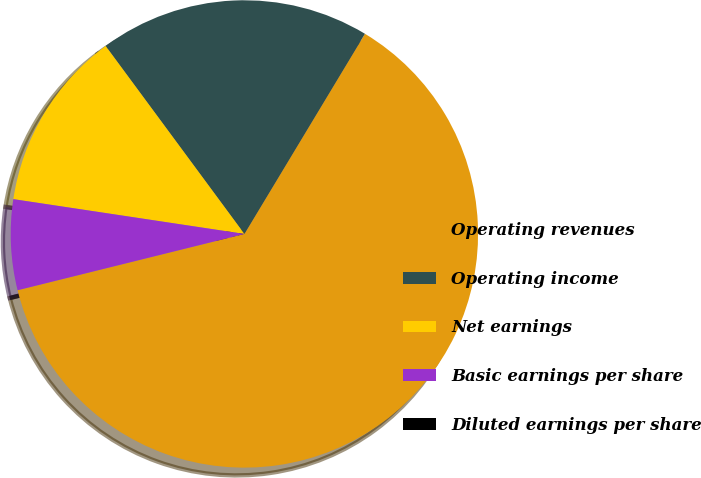Convert chart. <chart><loc_0><loc_0><loc_500><loc_500><pie_chart><fcel>Operating revenues<fcel>Operating income<fcel>Net earnings<fcel>Basic earnings per share<fcel>Diluted earnings per share<nl><fcel>62.5%<fcel>18.75%<fcel>12.5%<fcel>6.25%<fcel>0.0%<nl></chart> 